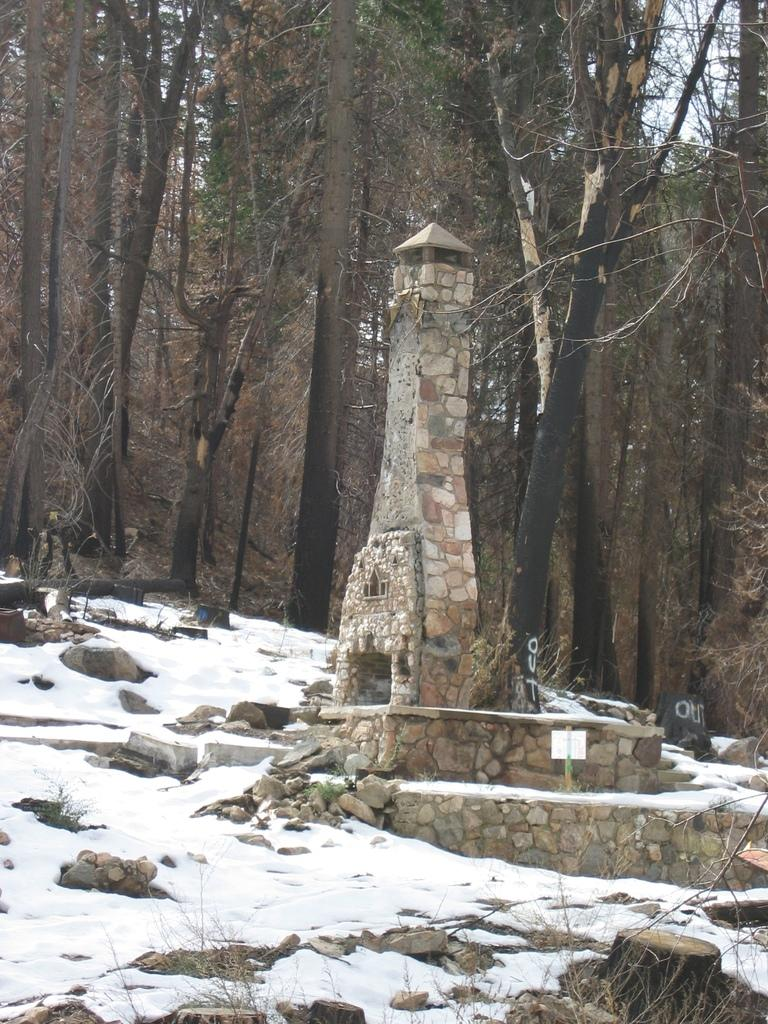What type of structure is depicted in the image? There is an architecture in the image. What can be seen in the background of the image? There are trees and the sky visible in the background of the image. What is present in the front of the architecture? There are stones and snow in the front of the architecture. What type of love can be seen in the image? There is no love present in the image; it features an architecture with trees, sky, stones, and snow. Is there a mine visible in the image? There is no mine present in the image. 